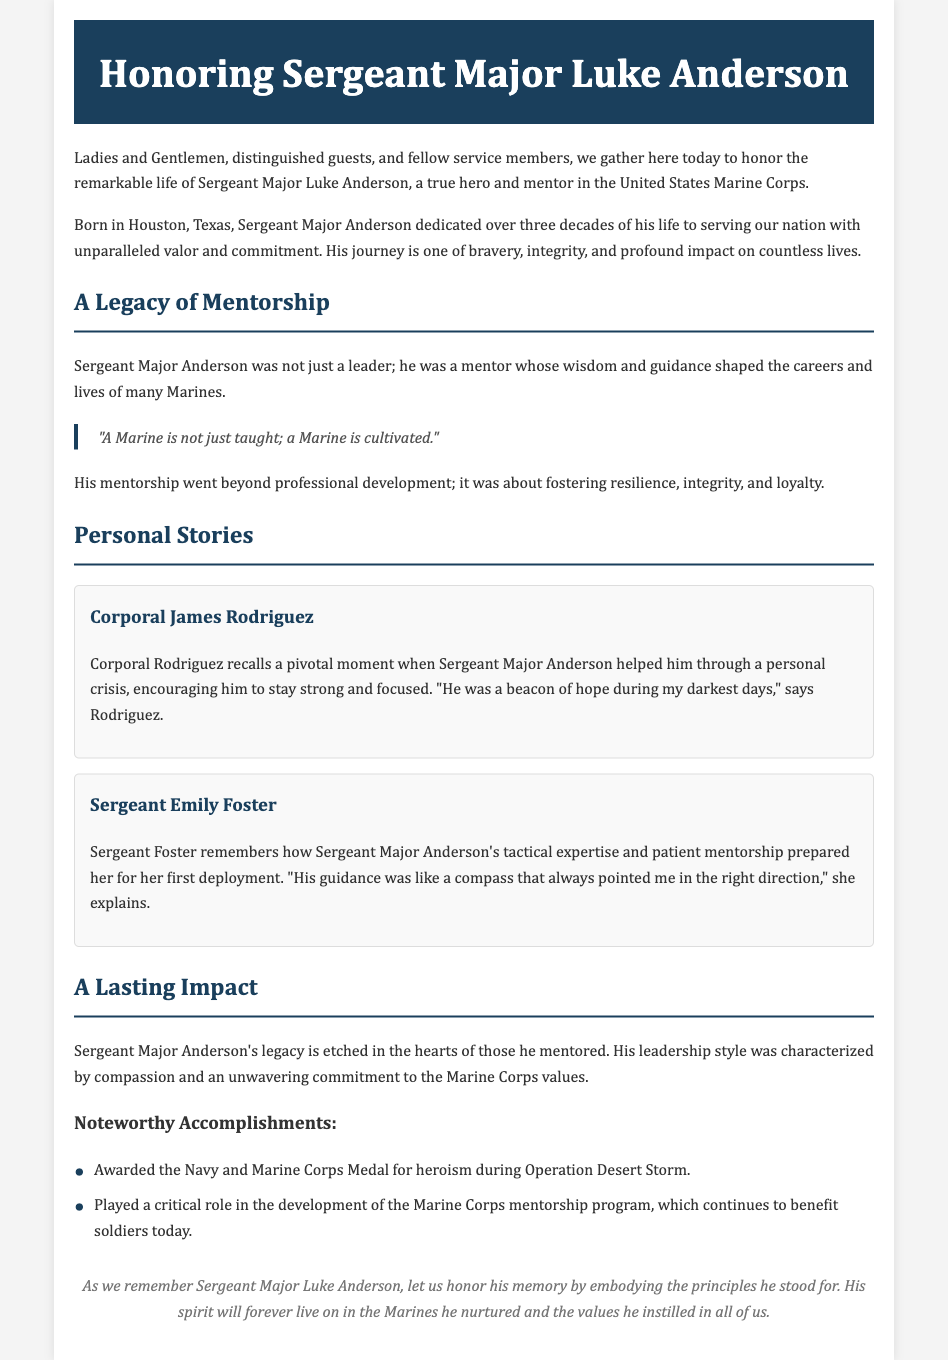What is the full name of the individual being honored? The document focuses on the life and impact of Sergeant Major Luke Anderson, as stated in the introduction.
Answer: Sergeant Major Luke Anderson How long did Sergeant Major Anderson serve in the Marine Corps? The document mentions that he dedicated over three decades to serving the nation, providing insight into his commitment.
Answer: Over three decades What crisis did Corporal Rodriguez say Sergeant Major Anderson helped him through? Corporal Rodriguez describes a personal crisis he faced, where Sergeant Major Anderson provided support and guidance.
Answer: Personal crisis What was Sergeant Foster's experience regarding her first deployment? The document states that Sergeant Major Anderson's mentorship and tactical expertise prepared Sergeant Foster for her first deployment.
Answer: Prepared her for her first deployment Which medal was awarded to Sergeant Major Anderson for heroism? The document specifically states that he was awarded the Navy and Marine Corps Medal for heroism during Operation Desert Storm.
Answer: Navy and Marine Corps Medal What key program did Sergeant Major Anderson help develop? The document notes his critical role in the development of the Marine Corps mentorship program, emphasizing the lasting impact of his contributions.
Answer: Marine Corps mentorship program What phrase reflects Sergeant Major Anderson's mentoring philosophy? The document contains a quote that encapsulates his view on mentorship within the Marine Corps.
Answer: "A Marine is not just taught; a Marine is cultivated." Which city was Sergeant Major Anderson born in? The document begins with mentioning that he was born in Houston, Texas, which provides personal context about him.
Answer: Houston, Texas What was a characteristic of Sergeant Major Anderson's leadership style? The document elaborates on his compassionate leadership style, highlighting one of the qualities that made him an effective mentor.
Answer: Compassionate 